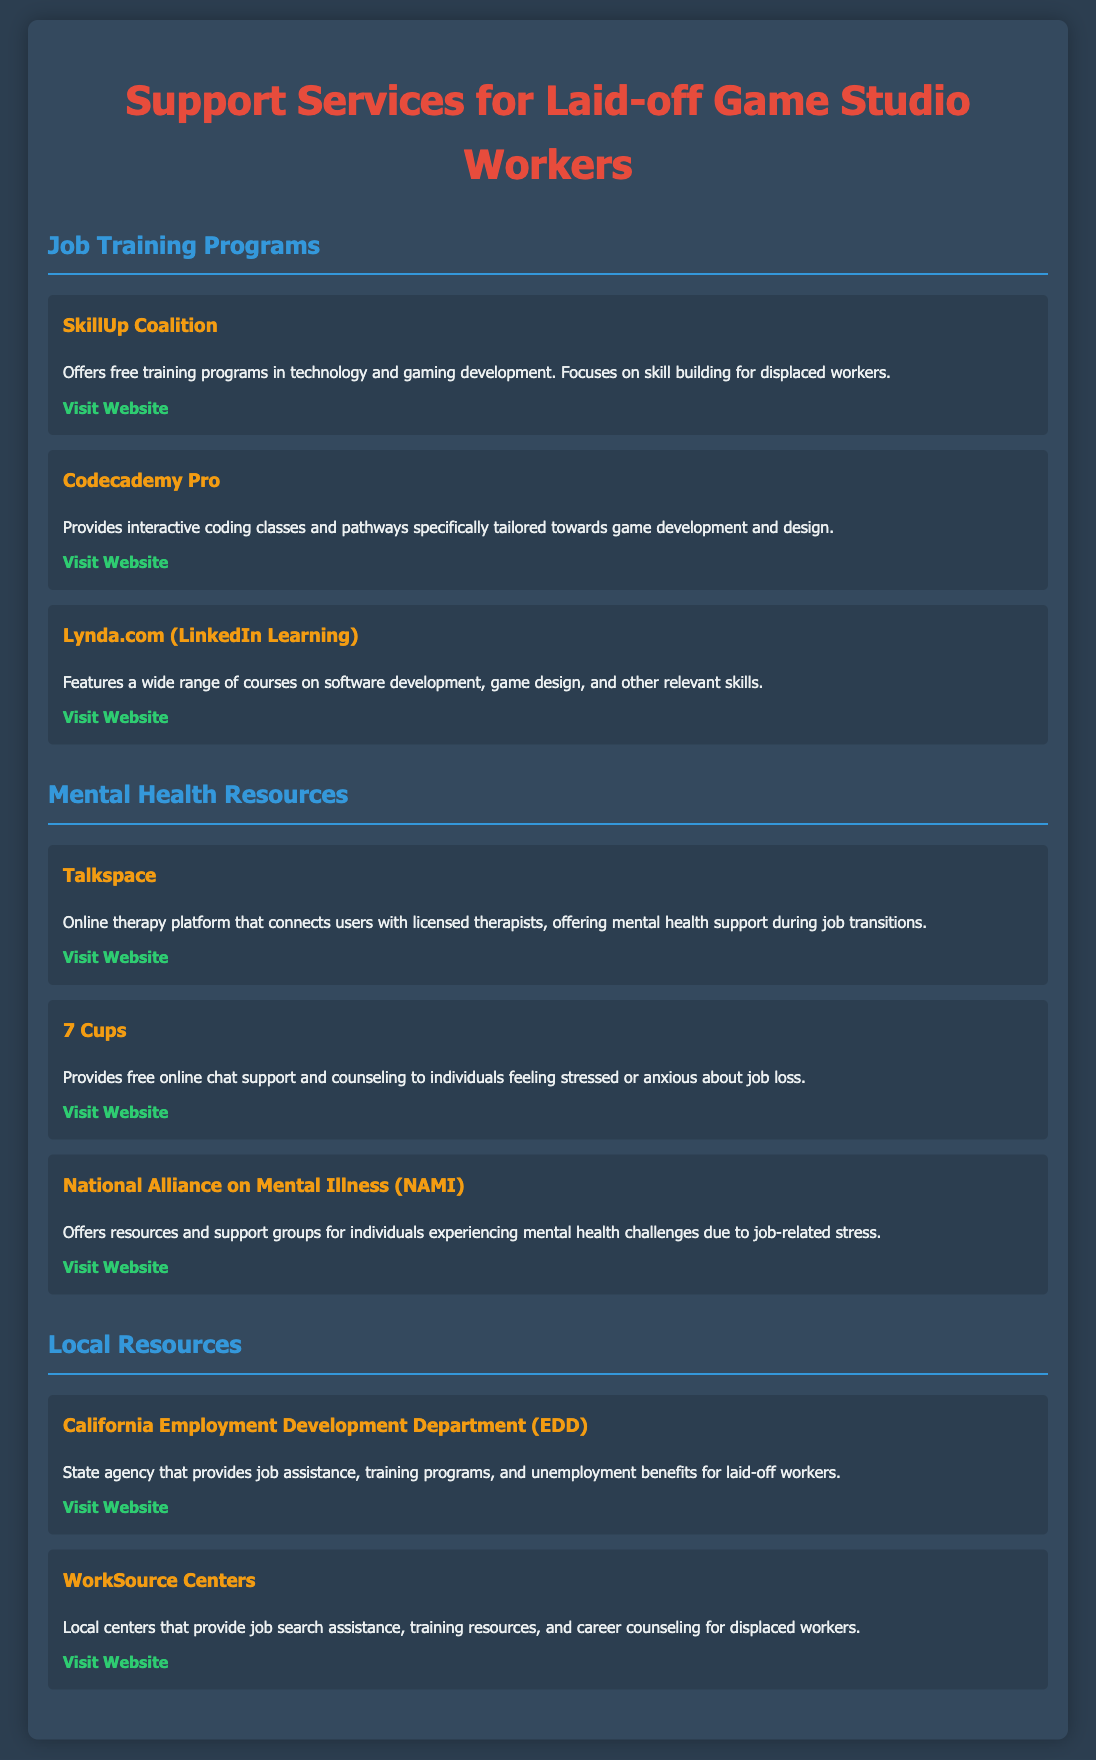what is the name of the online therapy platform? The document lists "Talkspace" as an online therapy platform for mental health support.
Answer: Talkspace how many job training programs are listed? There are three job training programs mentioned in the document under "Job Training Programs."
Answer: 3 what local resource assists with unemployment benefits? The document mentions the "California Employment Development Department (EDD)" as a local resource providing unemployment benefits.
Answer: California Employment Development Department (EDD) which platform offers free online chat support? "7 Cups" is the platform mentioned that provides free online chat support and counseling.
Answer: 7 Cups what is the focus of the SkillUp Coalition? The document indicates that the SkillUp Coalition focuses on skill building for displaced workers through free training programs.
Answer: Skill building for displaced workers how many mental health resources are listed? There are three mental health resources outlined in the document.
Answer: 3 what is the main purpose of WorkSource Centers? The document states that WorkSource Centers provide job search assistance and training resources for displaced workers.
Answer: Job search assistance and training resources which online learning platform offers coding classes tailored toward game development? The document lists "Codecademy Pro" as the platform that offers interactive coding classes specifically for game development.
Answer: Codecademy Pro 